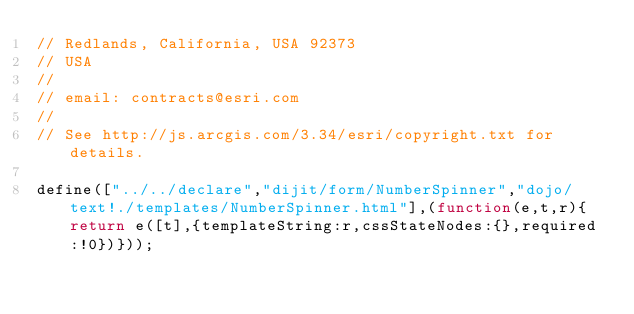<code> <loc_0><loc_0><loc_500><loc_500><_JavaScript_>// Redlands, California, USA 92373
// USA
//
// email: contracts@esri.com
//
// See http://js.arcgis.com/3.34/esri/copyright.txt for details.

define(["../../declare","dijit/form/NumberSpinner","dojo/text!./templates/NumberSpinner.html"],(function(e,t,r){return e([t],{templateString:r,cssStateNodes:{},required:!0})}));</code> 